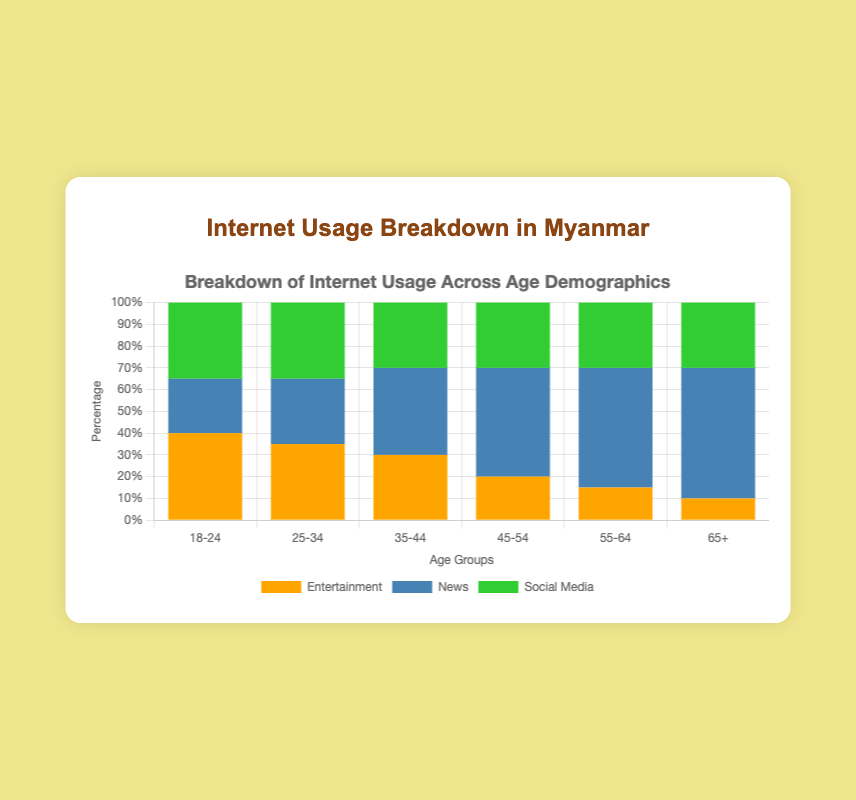What is the total percentage of internet usage for entertainment across all age groups? To find the total percentage of internet usage for entertainment across all age groups, we sum the percentages for each group: 40 + 35 + 30 + 20 + 15 + 10 = 150%
Answer: 150% In which age group is the proportion of internet usage for news the highest? By comparing the heights of the bars for news usage across all age groups, the highest proportion is found in the age group 65+, which has 60%.
Answer: 65+ Which age group has the smallest proportion of internet usage for social media? By inspecting the bars for social media usage across all age groups, all age groups except the 18-24 age group have an equal percentage of 30%. Only the 18-24 group has a higher proportion (35%). Thus, 35-44, 45-54, 55-64, and 65+ all tie for the smallest proportion of 30%.
Answer: 35-44, 45-54, 55-64, 65+ Does the age group 25-34 use the internet equally for news and social media? By examining the labels for the 25-34 age group, the bars show 30% for news and 35% for social media, indicating they do not use the internet equally for these two purposes.
Answer: No What is the overall percentage of internet usage for entertainment and social media combined in the age group 45-54? Adding the percentages for entertainment and social media in the 45-54 age group: 20 + 30 = 50%.
Answer: 50% For which age group is the proportion of internet usage for news double that of entertainment? Checking the figures shows that for the age group 45-54, the proportion for news (50%) is exactly double that for entertainment (20%).
Answer: 45-54 How does the proportion of entertainment usage in the 18-24 age group compare to the proportion of news usage in the 65+ age group? The proportion of entertainment usage in the 18-24 age group is 40%, while the proportion for news usage in the 65+ age group is 60%.
Answer: 40% vs 60% What is the difference in social media usage between the 18-24 and 35-44 age groups? The proportion for social media usage in the 18-24 age group is 35%, and for the 35-44 age group, it is 30%. The difference is 35 - 30 = 5%.
Answer: 5% 